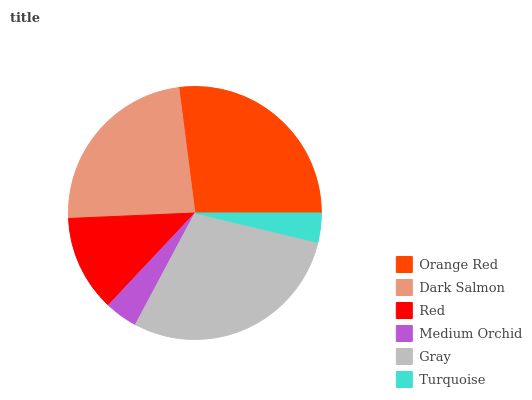Is Turquoise the minimum?
Answer yes or no. Yes. Is Gray the maximum?
Answer yes or no. Yes. Is Dark Salmon the minimum?
Answer yes or no. No. Is Dark Salmon the maximum?
Answer yes or no. No. Is Orange Red greater than Dark Salmon?
Answer yes or no. Yes. Is Dark Salmon less than Orange Red?
Answer yes or no. Yes. Is Dark Salmon greater than Orange Red?
Answer yes or no. No. Is Orange Red less than Dark Salmon?
Answer yes or no. No. Is Dark Salmon the high median?
Answer yes or no. Yes. Is Red the low median?
Answer yes or no. Yes. Is Orange Red the high median?
Answer yes or no. No. Is Medium Orchid the low median?
Answer yes or no. No. 